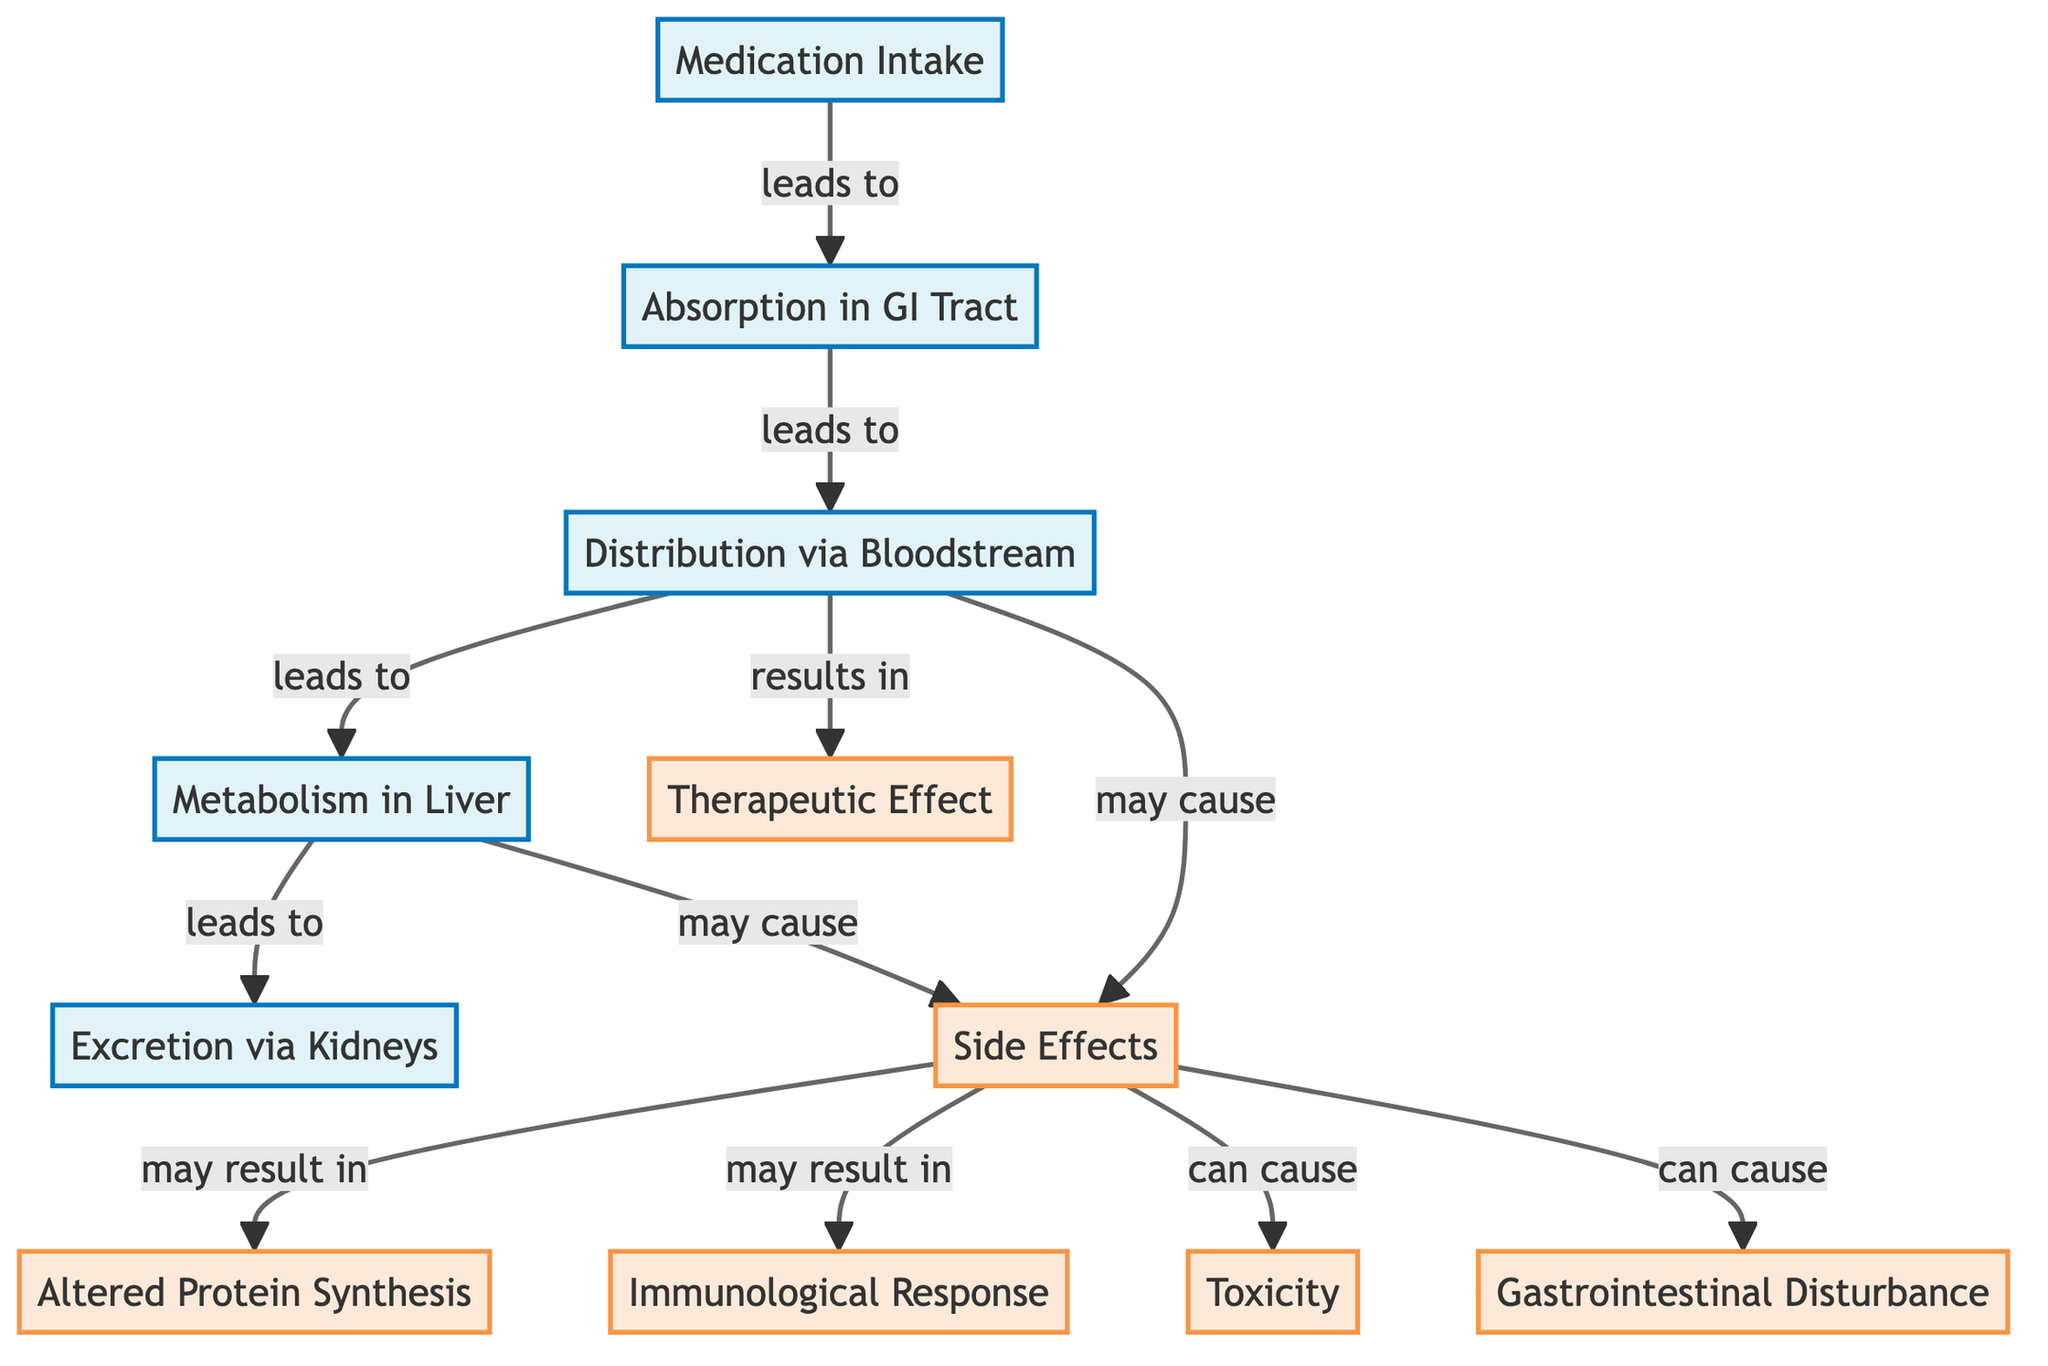What leads to absorption? The diagram shows that "Medication Intake" leads to "Absorption in GI Tract." This indicates that the process of taking medication directly results in its absorption.
Answer: Medication Intake What occurs after metabolism? According to the diagram, "Excretion via Kidneys" occurs after "Metabolism in Liver." This flow indicates that the metabolic processes in the liver lead to the excretion of substances through the kidneys.
Answer: Excretion via Kidneys How many nodes are related to side effects? The diagram identifies four types of outcomes stemming from "Side Effects": "Altered Protein Synthesis," "Immunological Response," "Toxicity," and "Gastrointestinal Disturbance." Thus, there are four nodes directly linked to side effects.
Answer: 4 What can cause gastrointestinal disturbance? The diagram illustrates that "Side Effects" can cause "Gastrointestinal Disturbance." This shows a direct relationship where side effects contribute to gastrointestinal issues.
Answer: Side Effects Which process leads to therapeutic effect? From the diagram, "Distribution via Bloodstream" is shown as leading to the "Therapeutic Effect." This means that when the medication is distributed in the bloodstream, it can produce the desired therapeutic outcomes.
Answer: Distribution via Bloodstream Which processes can cause side effects? The diagram states that both "Distribution via Bloodstream" and "Metabolism in Liver" may result in "Side Effects." This indicates two distinct processes that can lead to undesired effects from medication.
Answer: Distribution via Bloodstream, Metabolism in Liver What is altered due to side effects? The diagram specifies that "Altered Protein Synthesis" may result from "Side Effects." This indicates that one of the phenomena that can be impacted by medication side effects is the process of protein synthesis.
Answer: Altered Protein Synthesis Which component is affected by distribution? Both "Therapeutic Effect" and "Side Effects" are affected by "Distribution via Bloodstream" according to the diagram. It indicates that distribution has a dual outcome: it can provide therapeutic benefits or lead to side effects.
Answer: Therapeutic Effect, Side Effects What happens after absorption? The diagram indicates that "Absorption in GI Tract" leads to "Distribution via Bloodstream." Therefore, after absorption occurs, the next step is distribution, which refers to the spreading of medication throughout the body.
Answer: Distribution via Bloodstream 